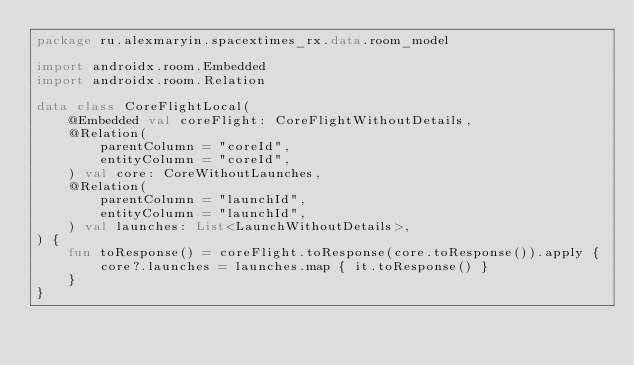<code> <loc_0><loc_0><loc_500><loc_500><_Kotlin_>package ru.alexmaryin.spacextimes_rx.data.room_model

import androidx.room.Embedded
import androidx.room.Relation

data class CoreFlightLocal(
    @Embedded val coreFlight: CoreFlightWithoutDetails,
    @Relation(
        parentColumn = "coreId",
        entityColumn = "coreId",
    ) val core: CoreWithoutLaunches,
    @Relation(
        parentColumn = "launchId",
        entityColumn = "launchId",
    ) val launches: List<LaunchWithoutDetails>,
) {
    fun toResponse() = coreFlight.toResponse(core.toResponse()).apply {
        core?.launches = launches.map { it.toResponse() }
    }
}
</code> 